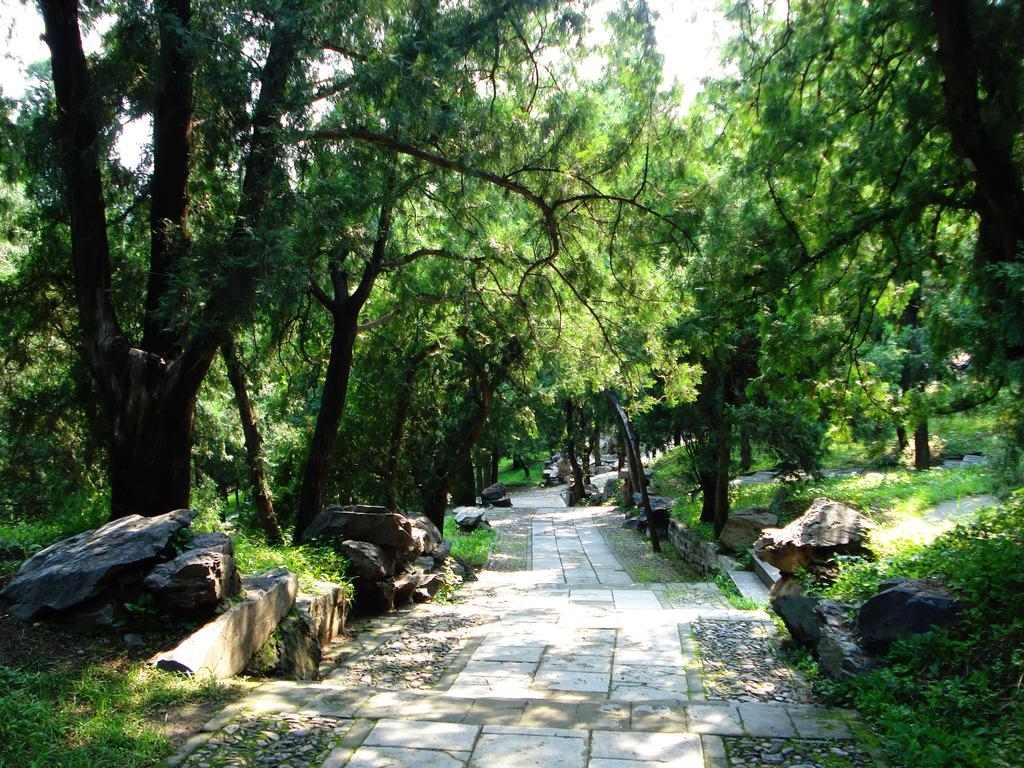What can be seen on both sides of the image? There are rocks and trees on both the left and right sides of the image. What is the pathway made of in the image? The walkway in between the trees and rocks is not specified, but it is visible in the image. How are the trees and rocks arranged in the image? The trees and rocks are arranged on both sides of the walkway. Can you see a stream flowing through the walkway in the image? There is no mention of a stream in the provided facts, and therefore it cannot be confirmed or denied if a stream is present in the image. 